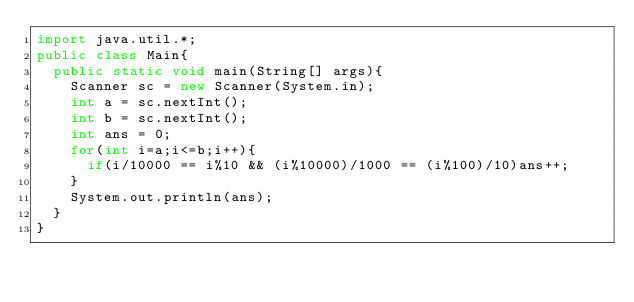Convert code to text. <code><loc_0><loc_0><loc_500><loc_500><_Java_>import java.util.*;
public class Main{
  public static void main(String[] args){
    Scanner sc = new Scanner(System.in);
    int a = sc.nextInt();
    int b = sc.nextInt();
    int ans = 0;
    for(int i=a;i<=b;i++){
      if(i/10000 == i%10 && (i%10000)/1000 == (i%100)/10)ans++;
    }
    System.out.println(ans);
  }
}</code> 